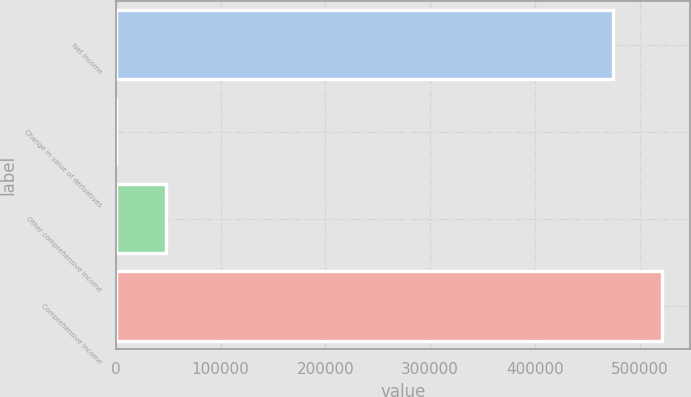Convert chart. <chart><loc_0><loc_0><loc_500><loc_500><bar_chart><fcel>Net income<fcel>Change in value of derivatives<fcel>Other comprehensive income<fcel>Comprehensive income<nl><fcel>474338<fcel>105<fcel>47538.8<fcel>521772<nl></chart> 